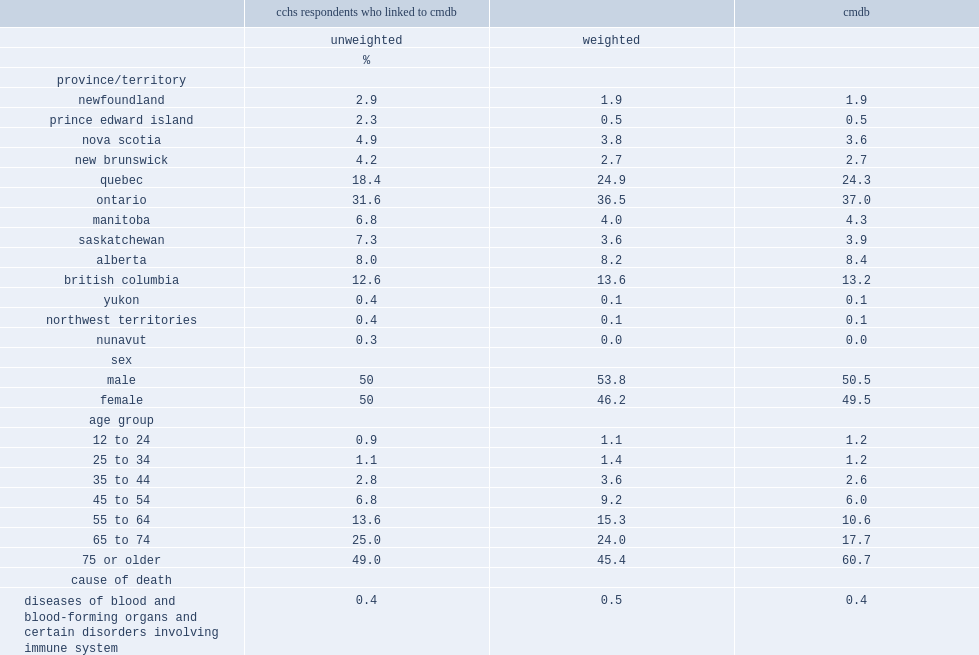List three largest provinces where the majority of deaths occurred. Ontario quebec british columbia. What percentage of all deaths were among people aged 75 or older in the linked data? 49.0. What percentage of all deaths were among people aged 75 or older in the cmdb data? 60.7. 